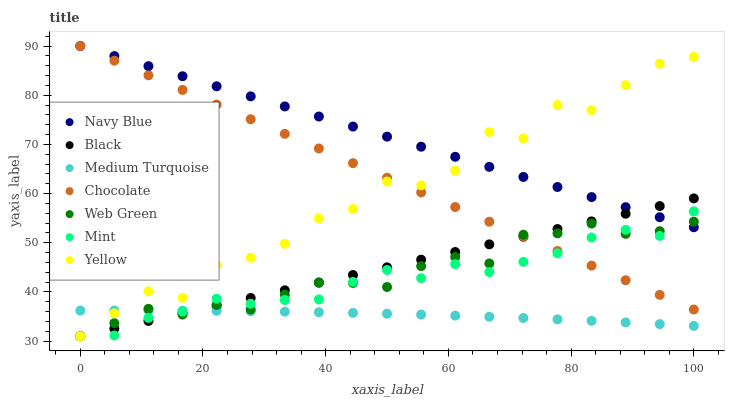Does Medium Turquoise have the minimum area under the curve?
Answer yes or no. Yes. Does Navy Blue have the maximum area under the curve?
Answer yes or no. Yes. Does Web Green have the minimum area under the curve?
Answer yes or no. No. Does Web Green have the maximum area under the curve?
Answer yes or no. No. Is Black the smoothest?
Answer yes or no. Yes. Is Yellow the roughest?
Answer yes or no. Yes. Is Web Green the smoothest?
Answer yes or no. No. Is Web Green the roughest?
Answer yes or no. No. Does Black have the lowest value?
Answer yes or no. Yes. Does Web Green have the lowest value?
Answer yes or no. No. Does Chocolate have the highest value?
Answer yes or no. Yes. Does Web Green have the highest value?
Answer yes or no. No. Is Medium Turquoise less than Navy Blue?
Answer yes or no. Yes. Is Navy Blue greater than Medium Turquoise?
Answer yes or no. Yes. Does Navy Blue intersect Web Green?
Answer yes or no. Yes. Is Navy Blue less than Web Green?
Answer yes or no. No. Is Navy Blue greater than Web Green?
Answer yes or no. No. Does Medium Turquoise intersect Navy Blue?
Answer yes or no. No. 